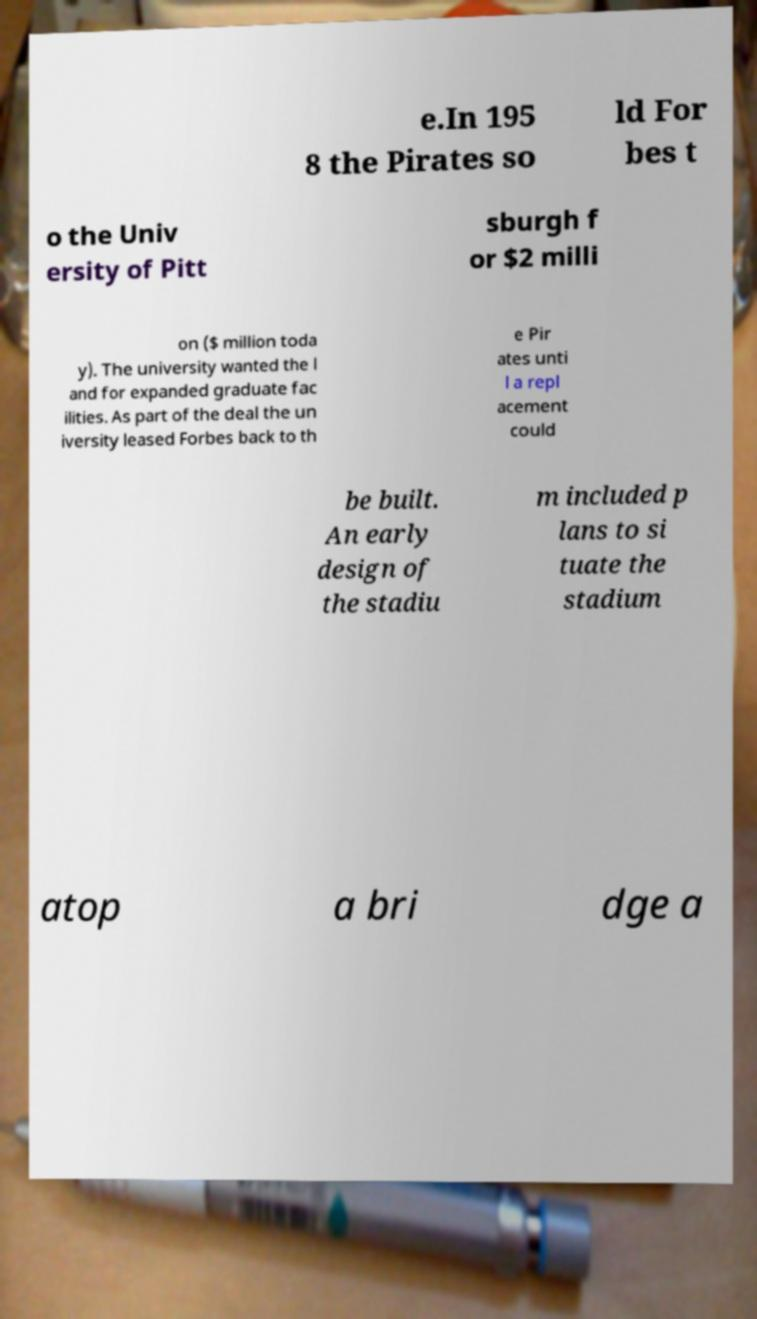Can you accurately transcribe the text from the provided image for me? e.In 195 8 the Pirates so ld For bes t o the Univ ersity of Pitt sburgh f or $2 milli on ($ million toda y). The university wanted the l and for expanded graduate fac ilities. As part of the deal the un iversity leased Forbes back to th e Pir ates unti l a repl acement could be built. An early design of the stadiu m included p lans to si tuate the stadium atop a bri dge a 